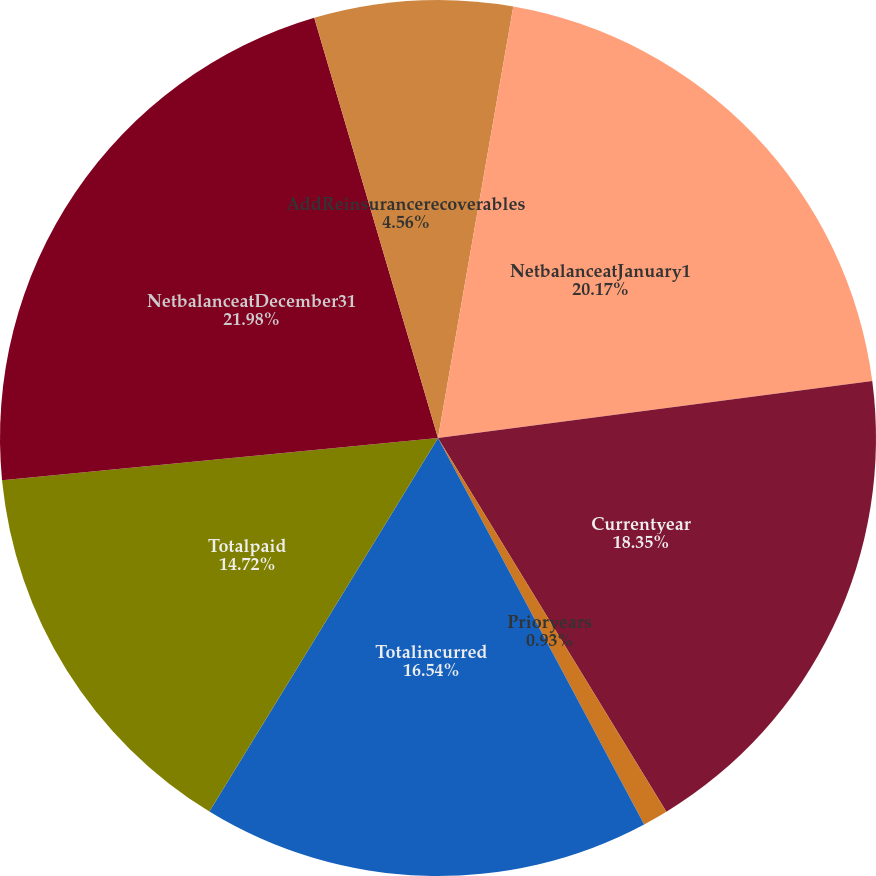Convert chart to OTSL. <chart><loc_0><loc_0><loc_500><loc_500><pie_chart><fcel>LessReinsurancerecoverables<fcel>NetbalanceatJanuary1<fcel>Currentyear<fcel>Prioryears<fcel>Totalincurred<fcel>Totalpaid<fcel>NetbalanceatDecember31<fcel>AddReinsurancerecoverables<nl><fcel>2.75%<fcel>20.17%<fcel>18.35%<fcel>0.93%<fcel>16.54%<fcel>14.72%<fcel>21.98%<fcel>4.56%<nl></chart> 